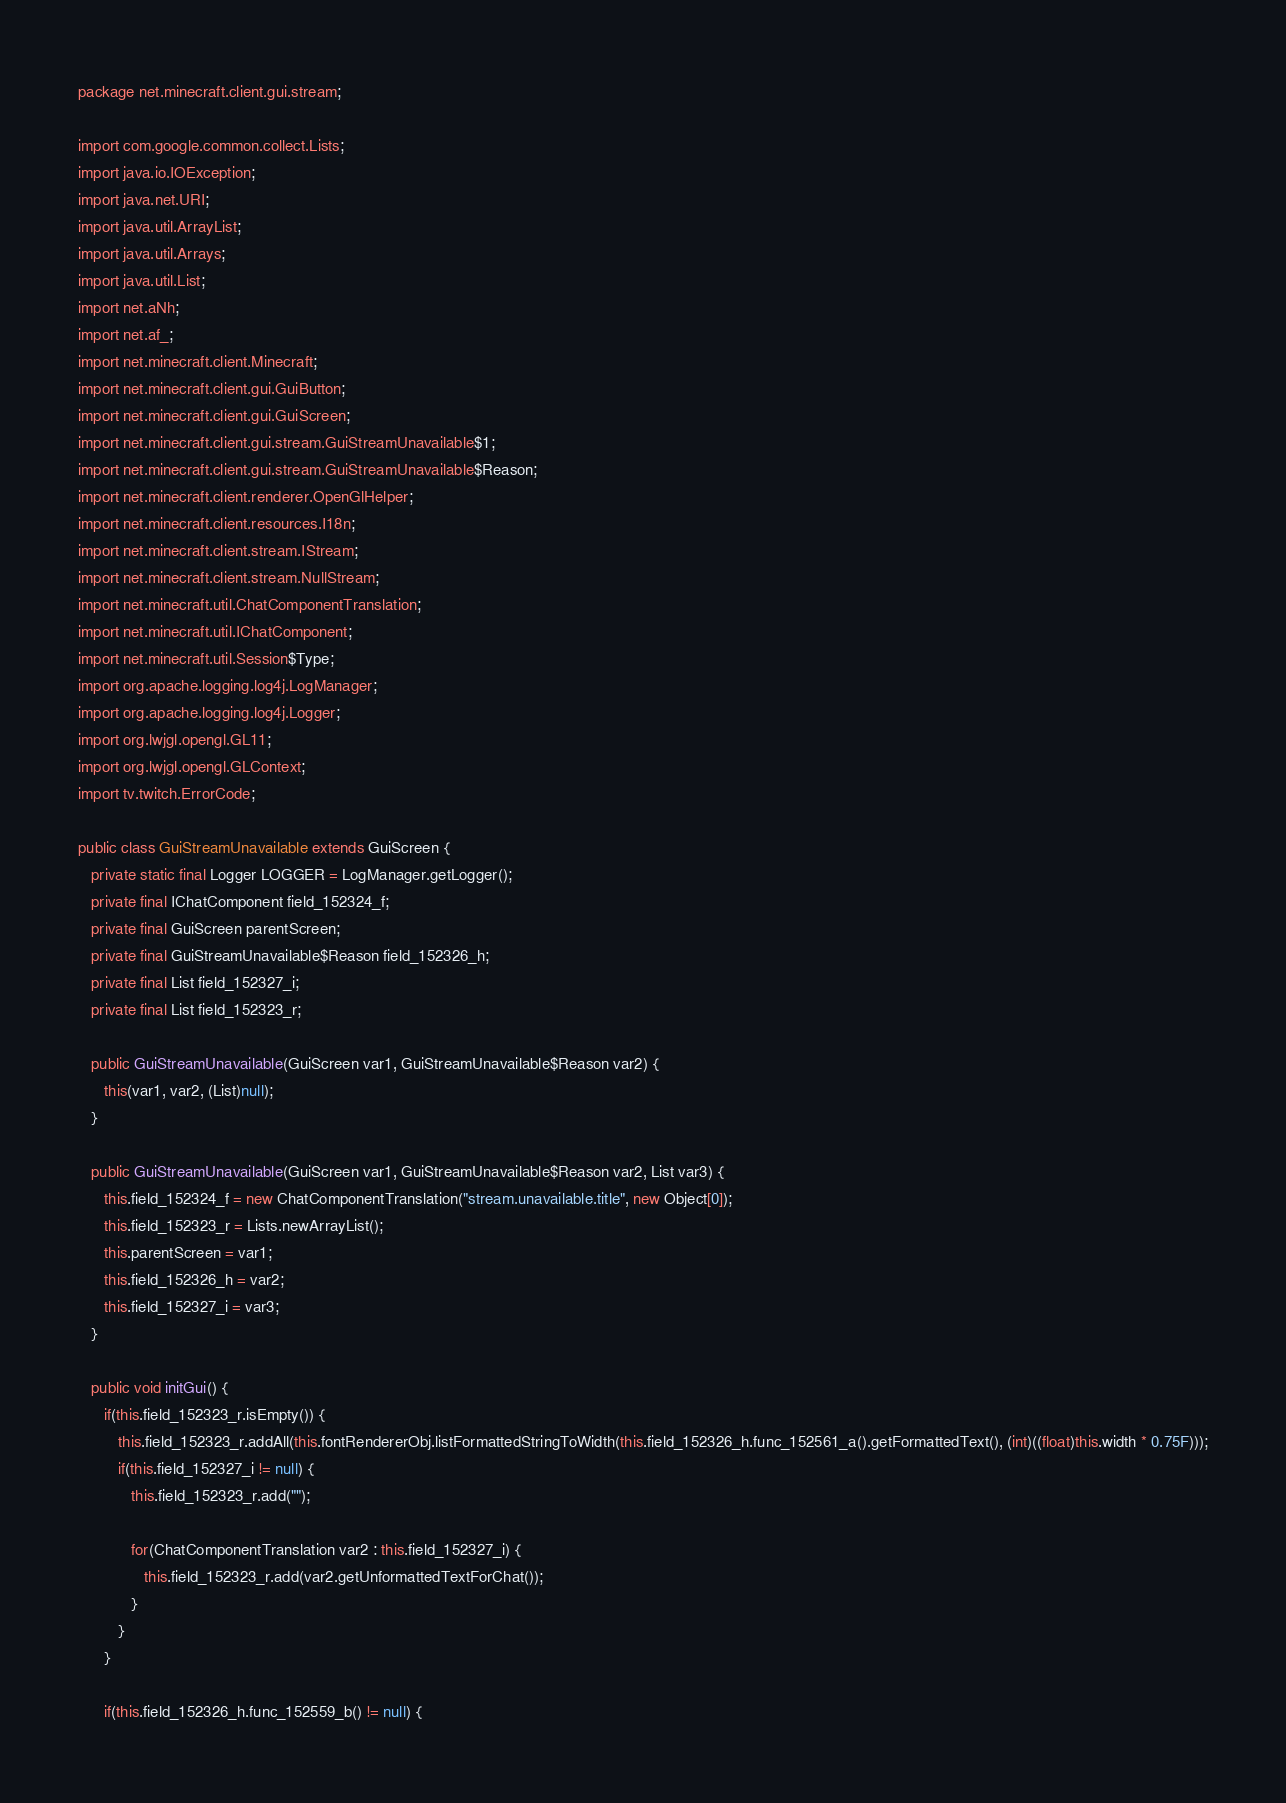Convert code to text. <code><loc_0><loc_0><loc_500><loc_500><_Java_>package net.minecraft.client.gui.stream;

import com.google.common.collect.Lists;
import java.io.IOException;
import java.net.URI;
import java.util.ArrayList;
import java.util.Arrays;
import java.util.List;
import net.aNh;
import net.af_;
import net.minecraft.client.Minecraft;
import net.minecraft.client.gui.GuiButton;
import net.minecraft.client.gui.GuiScreen;
import net.minecraft.client.gui.stream.GuiStreamUnavailable$1;
import net.minecraft.client.gui.stream.GuiStreamUnavailable$Reason;
import net.minecraft.client.renderer.OpenGlHelper;
import net.minecraft.client.resources.I18n;
import net.minecraft.client.stream.IStream;
import net.minecraft.client.stream.NullStream;
import net.minecraft.util.ChatComponentTranslation;
import net.minecraft.util.IChatComponent;
import net.minecraft.util.Session$Type;
import org.apache.logging.log4j.LogManager;
import org.apache.logging.log4j.Logger;
import org.lwjgl.opengl.GL11;
import org.lwjgl.opengl.GLContext;
import tv.twitch.ErrorCode;

public class GuiStreamUnavailable extends GuiScreen {
   private static final Logger LOGGER = LogManager.getLogger();
   private final IChatComponent field_152324_f;
   private final GuiScreen parentScreen;
   private final GuiStreamUnavailable$Reason field_152326_h;
   private final List field_152327_i;
   private final List field_152323_r;

   public GuiStreamUnavailable(GuiScreen var1, GuiStreamUnavailable$Reason var2) {
      this(var1, var2, (List)null);
   }

   public GuiStreamUnavailable(GuiScreen var1, GuiStreamUnavailable$Reason var2, List var3) {
      this.field_152324_f = new ChatComponentTranslation("stream.unavailable.title", new Object[0]);
      this.field_152323_r = Lists.newArrayList();
      this.parentScreen = var1;
      this.field_152326_h = var2;
      this.field_152327_i = var3;
   }

   public void initGui() {
      if(this.field_152323_r.isEmpty()) {
         this.field_152323_r.addAll(this.fontRendererObj.listFormattedStringToWidth(this.field_152326_h.func_152561_a().getFormattedText(), (int)((float)this.width * 0.75F)));
         if(this.field_152327_i != null) {
            this.field_152323_r.add("");

            for(ChatComponentTranslation var2 : this.field_152327_i) {
               this.field_152323_r.add(var2.getUnformattedTextForChat());
            }
         }
      }

      if(this.field_152326_h.func_152559_b() != null) {</code> 